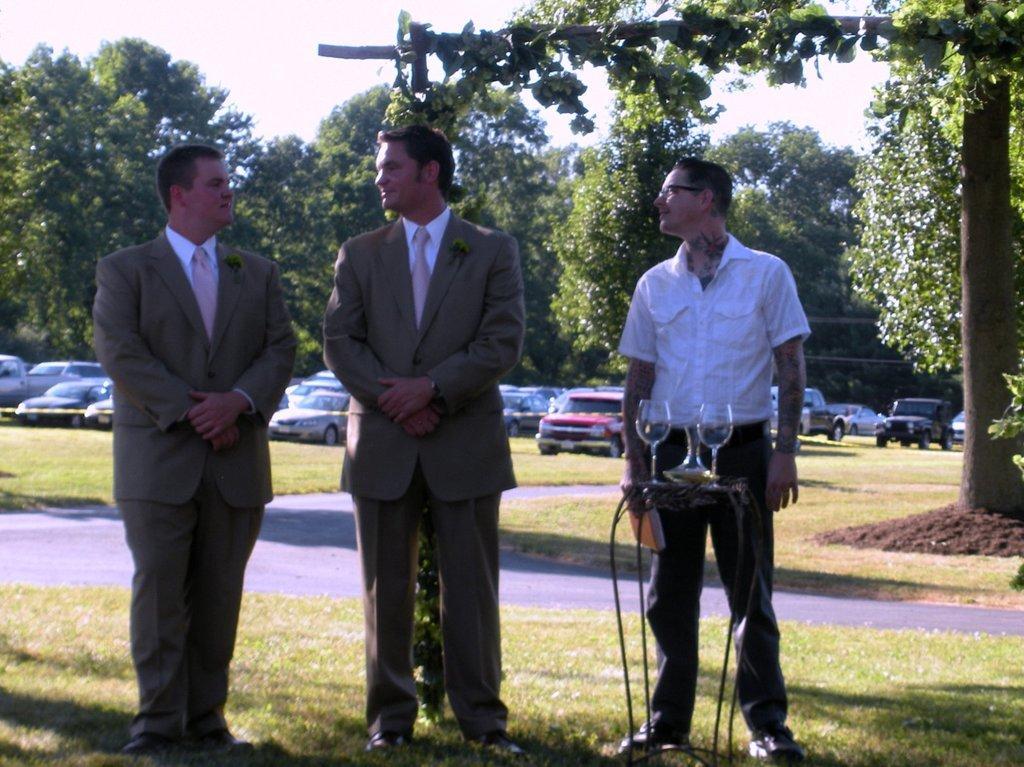How would you summarize this image in a sentence or two? In the image we can see three men standing, they are wearing clothes and shoes. This person is wearing spectacles. There is a table on the table there are wine glasses and a vase and there is a liquid in it. This is a grass, soil, road, trees and white sky. We can even see there are many vehicles. 